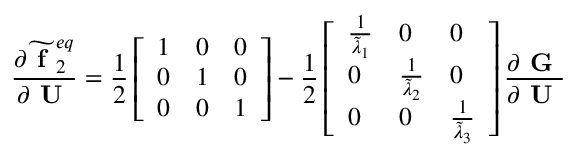<formula> <loc_0><loc_0><loc_500><loc_500>\frac { \partial \widetilde { f } _ { 2 } ^ { e q } } { \partial U } = \frac { 1 } { 2 } \left [ \begin{array} { l l l } { 1 } & { 0 } & { 0 } \\ { 0 } & { 1 } & { 0 } \\ { 0 } & { 0 } & { 1 } \end{array} \right ] - \frac { 1 } { 2 } \left [ \begin{array} { l l l } { \frac { 1 } { \widetilde { \lambda } _ { 1 } } } & { 0 } & { 0 } \\ { 0 } & { \frac { 1 } { \widetilde { \lambda } _ { 2 } } } & { 0 } \\ { 0 } & { 0 } & { \frac { 1 } { \widetilde { \lambda } _ { 3 } } } \end{array} \right ] \frac { \partial G } { \partial U }</formula> 